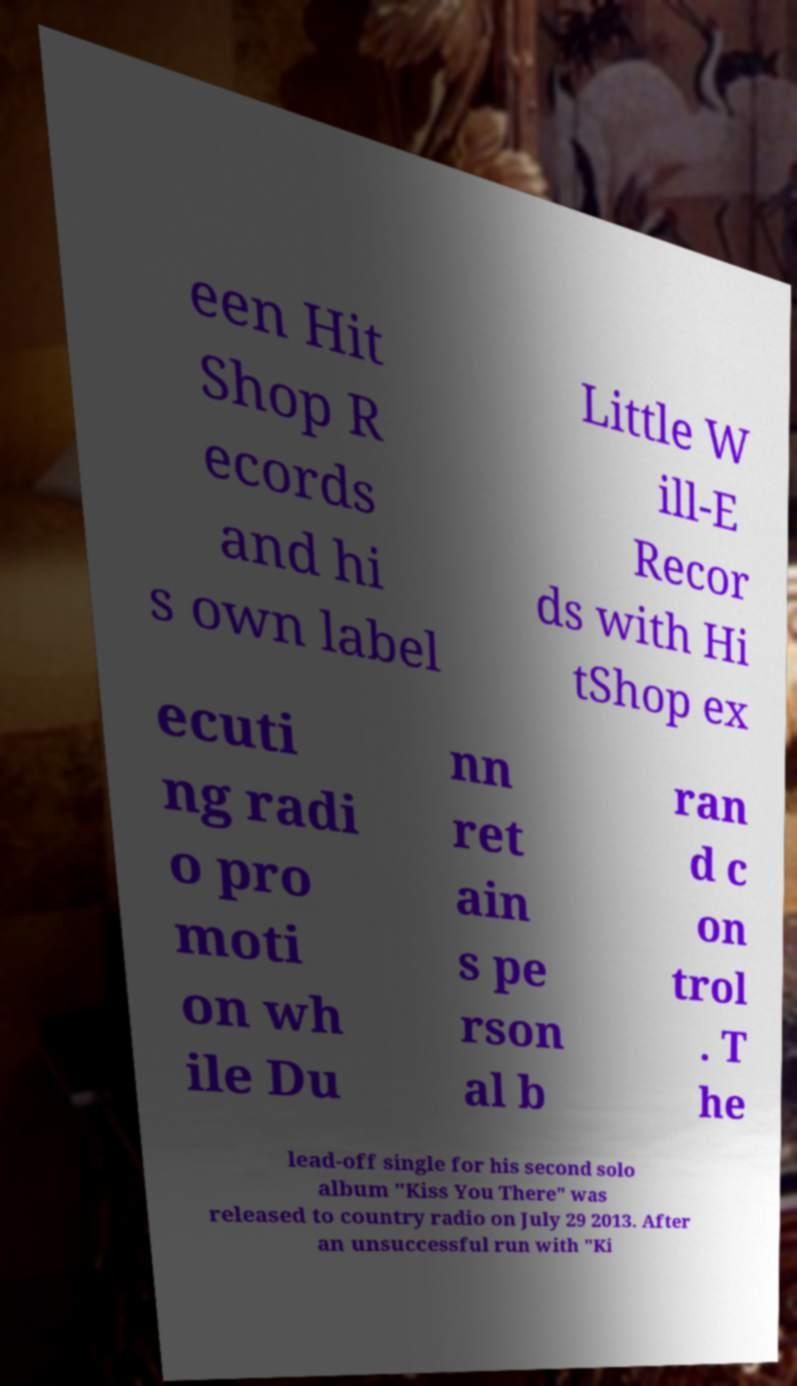Could you extract and type out the text from this image? een Hit Shop R ecords and hi s own label Little W ill-E Recor ds with Hi tShop ex ecuti ng radi o pro moti on wh ile Du nn ret ain s pe rson al b ran d c on trol . T he lead-off single for his second solo album "Kiss You There" was released to country radio on July 29 2013. After an unsuccessful run with "Ki 